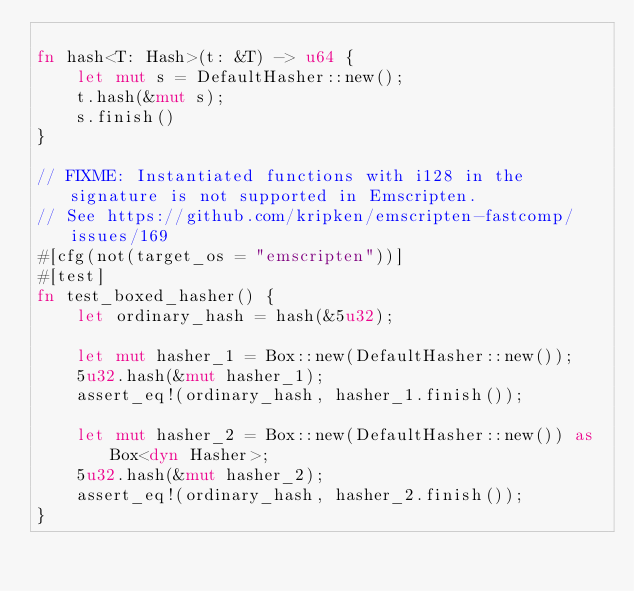<code> <loc_0><loc_0><loc_500><loc_500><_Rust_>
fn hash<T: Hash>(t: &T) -> u64 {
    let mut s = DefaultHasher::new();
    t.hash(&mut s);
    s.finish()
}

// FIXME: Instantiated functions with i128 in the signature is not supported in Emscripten.
// See https://github.com/kripken/emscripten-fastcomp/issues/169
#[cfg(not(target_os = "emscripten"))]
#[test]
fn test_boxed_hasher() {
    let ordinary_hash = hash(&5u32);

    let mut hasher_1 = Box::new(DefaultHasher::new());
    5u32.hash(&mut hasher_1);
    assert_eq!(ordinary_hash, hasher_1.finish());

    let mut hasher_2 = Box::new(DefaultHasher::new()) as Box<dyn Hasher>;
    5u32.hash(&mut hasher_2);
    assert_eq!(ordinary_hash, hasher_2.finish());
}
</code> 